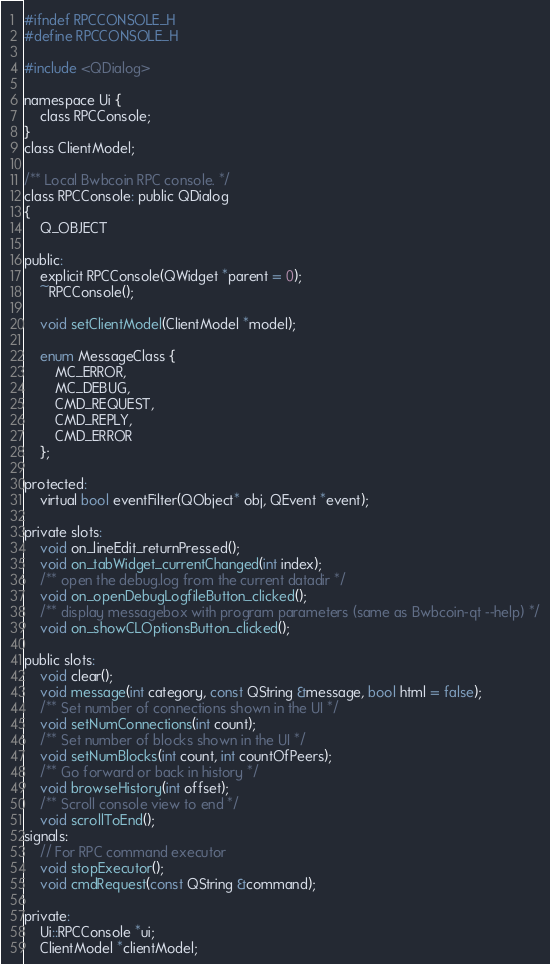<code> <loc_0><loc_0><loc_500><loc_500><_C_>#ifndef RPCCONSOLE_H
#define RPCCONSOLE_H

#include <QDialog>

namespace Ui {
    class RPCConsole;
}
class ClientModel;

/** Local Bwbcoin RPC console. */
class RPCConsole: public QDialog
{
    Q_OBJECT

public:
    explicit RPCConsole(QWidget *parent = 0);
    ~RPCConsole();

    void setClientModel(ClientModel *model);

    enum MessageClass {
        MC_ERROR,
        MC_DEBUG,
        CMD_REQUEST,
        CMD_REPLY,
        CMD_ERROR
    };

protected:
    virtual bool eventFilter(QObject* obj, QEvent *event);

private slots:
    void on_lineEdit_returnPressed();
    void on_tabWidget_currentChanged(int index);
    /** open the debug.log from the current datadir */
    void on_openDebugLogfileButton_clicked();
    /** display messagebox with program parameters (same as Bwbcoin-qt --help) */
    void on_showCLOptionsButton_clicked();

public slots:
    void clear();
    void message(int category, const QString &message, bool html = false);
    /** Set number of connections shown in the UI */
    void setNumConnections(int count);
    /** Set number of blocks shown in the UI */
    void setNumBlocks(int count, int countOfPeers);
    /** Go forward or back in history */
    void browseHistory(int offset);
    /** Scroll console view to end */
    void scrollToEnd();
signals:
    // For RPC command executor
    void stopExecutor();
    void cmdRequest(const QString &command);

private:
    Ui::RPCConsole *ui;
    ClientModel *clientModel;</code> 